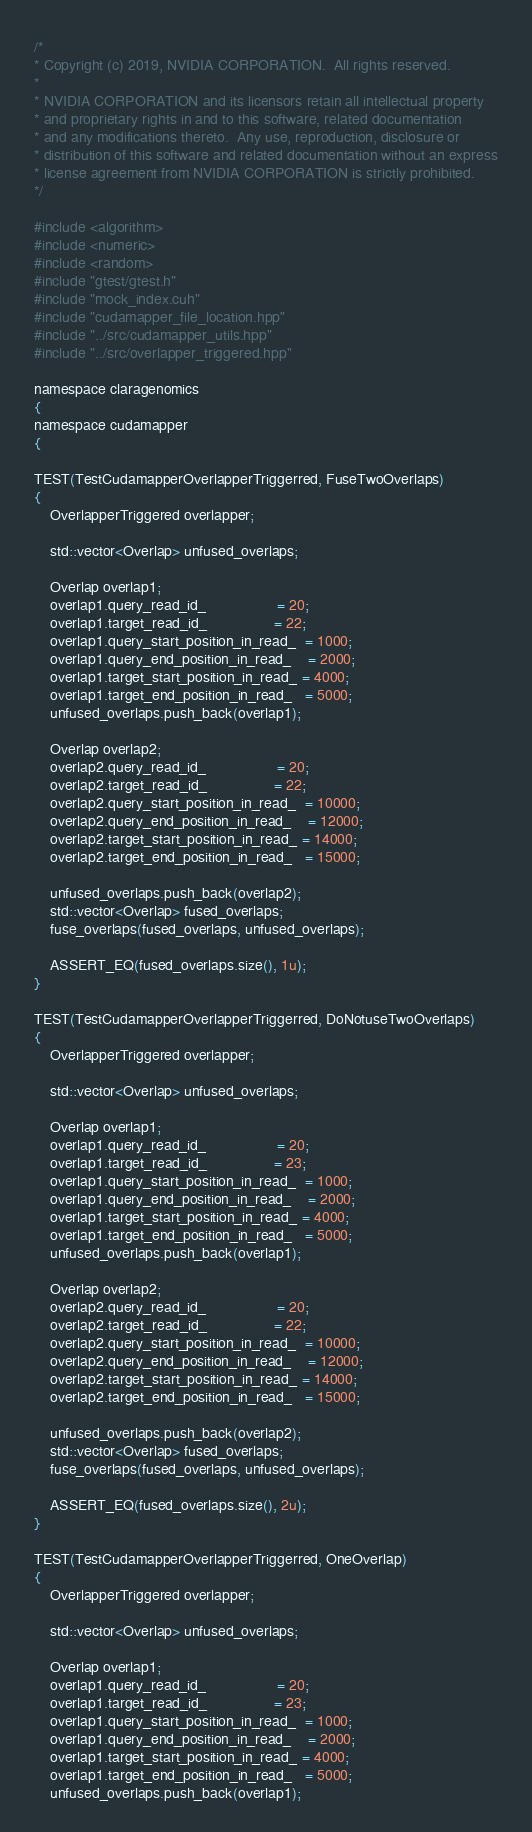Convert code to text. <code><loc_0><loc_0><loc_500><loc_500><_Cuda_>/*
* Copyright (c) 2019, NVIDIA CORPORATION.  All rights reserved.
*
* NVIDIA CORPORATION and its licensors retain all intellectual property
* and proprietary rights in and to this software, related documentation
* and any modifications thereto.  Any use, reproduction, disclosure or
* distribution of this software and related documentation without an express
* license agreement from NVIDIA CORPORATION is strictly prohibited.
*/

#include <algorithm>
#include <numeric>
#include <random>
#include "gtest/gtest.h"
#include "mock_index.cuh"
#include "cudamapper_file_location.hpp"
#include "../src/cudamapper_utils.hpp"
#include "../src/overlapper_triggered.hpp"

namespace claragenomics
{
namespace cudamapper
{

TEST(TestCudamapperOverlapperTriggerred, FuseTwoOverlaps)
{
    OverlapperTriggered overlapper;

    std::vector<Overlap> unfused_overlaps;

    Overlap overlap1;
    overlap1.query_read_id_                 = 20;
    overlap1.target_read_id_                = 22;
    overlap1.query_start_position_in_read_  = 1000;
    overlap1.query_end_position_in_read_    = 2000;
    overlap1.target_start_position_in_read_ = 4000;
    overlap1.target_end_position_in_read_   = 5000;
    unfused_overlaps.push_back(overlap1);

    Overlap overlap2;
    overlap2.query_read_id_                 = 20;
    overlap2.target_read_id_                = 22;
    overlap2.query_start_position_in_read_  = 10000;
    overlap2.query_end_position_in_read_    = 12000;
    overlap2.target_start_position_in_read_ = 14000;
    overlap2.target_end_position_in_read_   = 15000;

    unfused_overlaps.push_back(overlap2);
    std::vector<Overlap> fused_overlaps;
    fuse_overlaps(fused_overlaps, unfused_overlaps);

    ASSERT_EQ(fused_overlaps.size(), 1u);
}

TEST(TestCudamapperOverlapperTriggerred, DoNotuseTwoOverlaps)
{
    OverlapperTriggered overlapper;

    std::vector<Overlap> unfused_overlaps;

    Overlap overlap1;
    overlap1.query_read_id_                 = 20;
    overlap1.target_read_id_                = 23;
    overlap1.query_start_position_in_read_  = 1000;
    overlap1.query_end_position_in_read_    = 2000;
    overlap1.target_start_position_in_read_ = 4000;
    overlap1.target_end_position_in_read_   = 5000;
    unfused_overlaps.push_back(overlap1);

    Overlap overlap2;
    overlap2.query_read_id_                 = 20;
    overlap2.target_read_id_                = 22;
    overlap2.query_start_position_in_read_  = 10000;
    overlap2.query_end_position_in_read_    = 12000;
    overlap2.target_start_position_in_read_ = 14000;
    overlap2.target_end_position_in_read_   = 15000;

    unfused_overlaps.push_back(overlap2);
    std::vector<Overlap> fused_overlaps;
    fuse_overlaps(fused_overlaps, unfused_overlaps);

    ASSERT_EQ(fused_overlaps.size(), 2u);
}

TEST(TestCudamapperOverlapperTriggerred, OneOverlap)
{
    OverlapperTriggered overlapper;

    std::vector<Overlap> unfused_overlaps;

    Overlap overlap1;
    overlap1.query_read_id_                 = 20;
    overlap1.target_read_id_                = 23;
    overlap1.query_start_position_in_read_  = 1000;
    overlap1.query_end_position_in_read_    = 2000;
    overlap1.target_start_position_in_read_ = 4000;
    overlap1.target_end_position_in_read_   = 5000;
    unfused_overlaps.push_back(overlap1);
</code> 